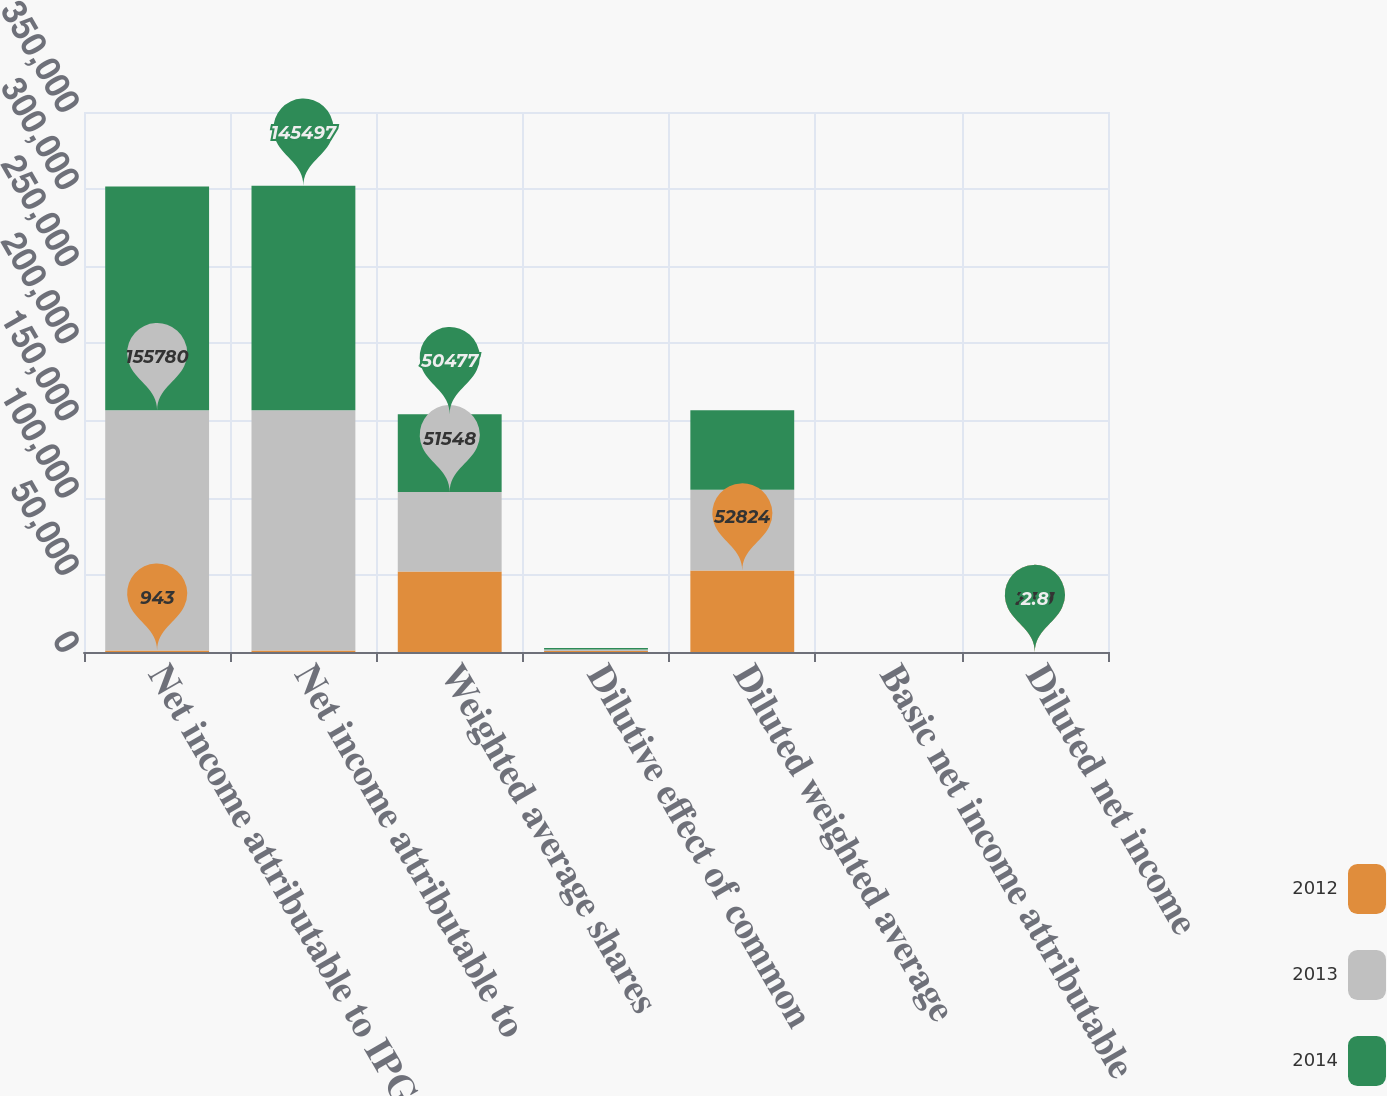Convert chart to OTSL. <chart><loc_0><loc_0><loc_500><loc_500><stacked_bar_chart><ecel><fcel>Net income attributable to IPG<fcel>Net income attributable to<fcel>Weighted average shares<fcel>Dilutive effect of common<fcel>Diluted weighted average<fcel>Basic net income attributable<fcel>Diluted net income<nl><fcel>2012<fcel>943<fcel>943<fcel>52104<fcel>720<fcel>52824<fcel>3.85<fcel>3.79<nl><fcel>2013<fcel>155780<fcel>155780<fcel>51548<fcel>827<fcel>52375<fcel>3.02<fcel>2.97<nl><fcel>2014<fcel>145004<fcel>145497<fcel>50477<fcel>1059<fcel>51536<fcel>2.87<fcel>2.8<nl></chart> 